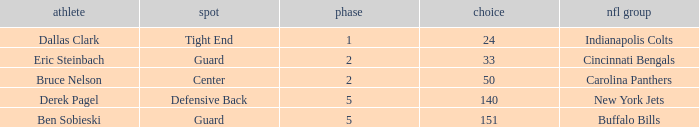During which round was a Hawkeyes player selected for the defensive back position? 5.0. 